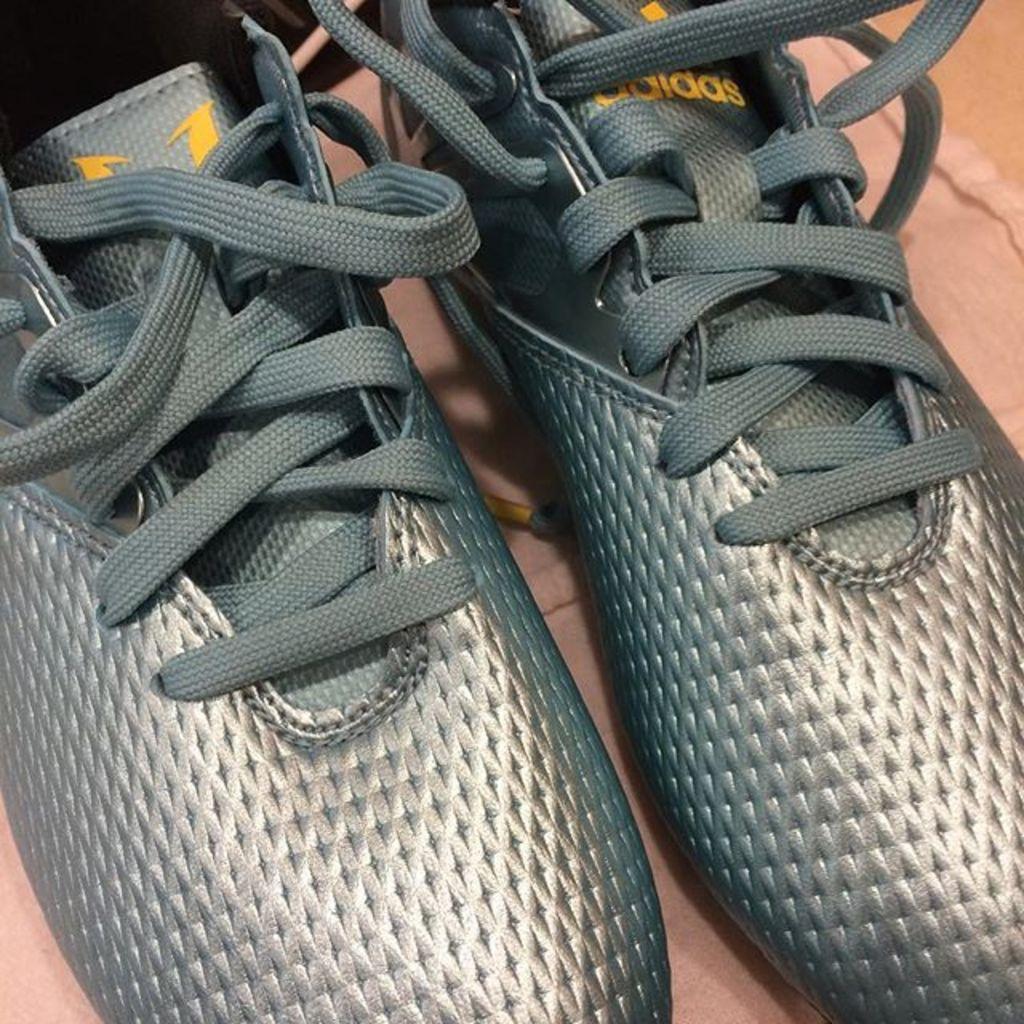Describe this image in one or two sentences. In this picture we can see shoes with laces are present on the floor. 